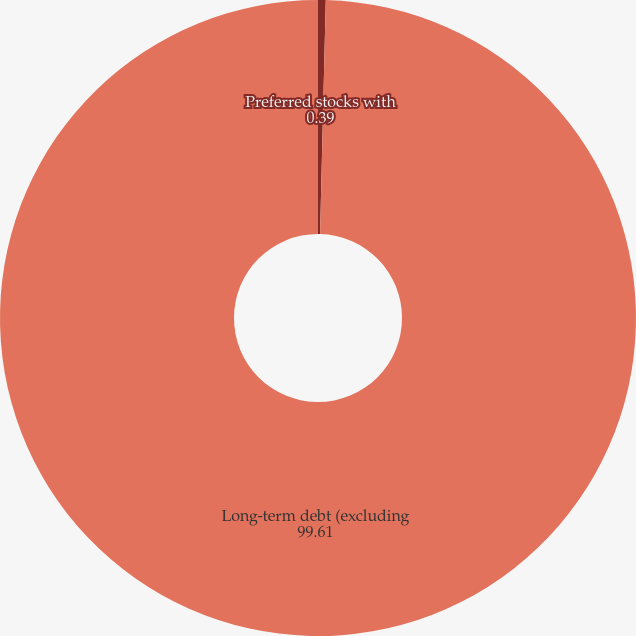Convert chart to OTSL. <chart><loc_0><loc_0><loc_500><loc_500><pie_chart><fcel>Preferred stocks with<fcel>Long-term debt (excluding<nl><fcel>0.39%<fcel>99.61%<nl></chart> 